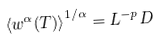Convert formula to latex. <formula><loc_0><loc_0><loc_500><loc_500>\left \langle w ^ { \alpha } ( T ) \right \rangle ^ { 1 / \alpha } = L ^ { - p } D</formula> 